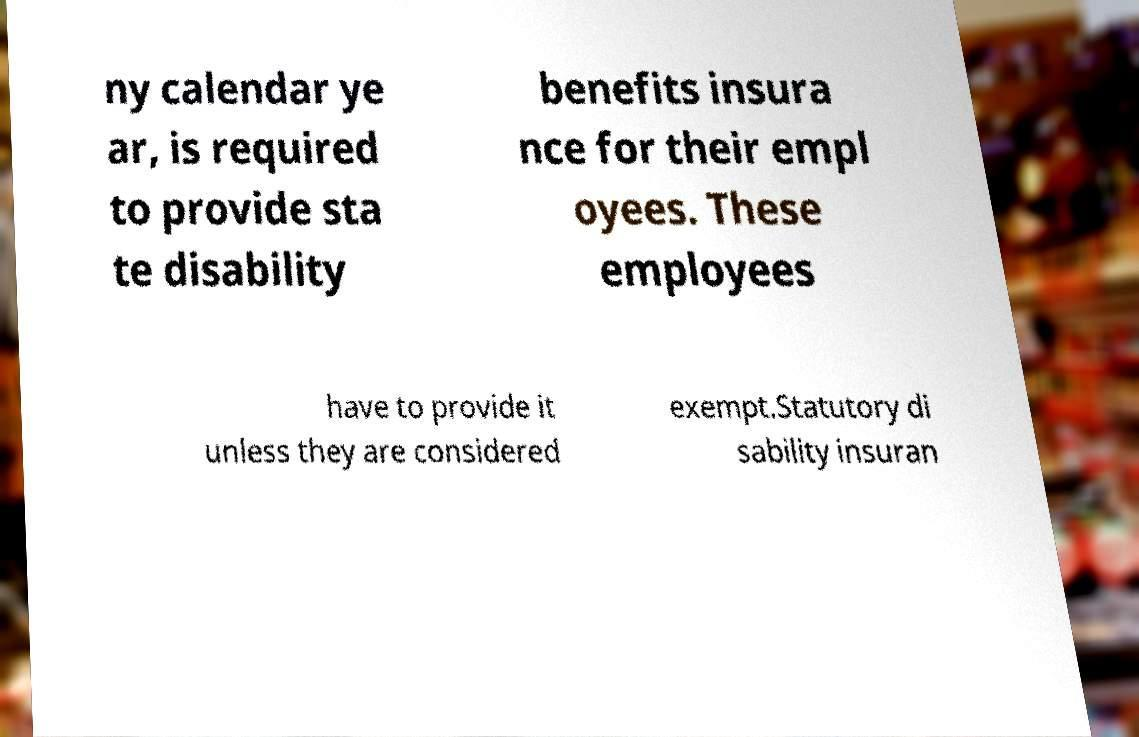There's text embedded in this image that I need extracted. Can you transcribe it verbatim? ny calendar ye ar, is required to provide sta te disability benefits insura nce for their empl oyees. These employees have to provide it unless they are considered exempt.Statutory di sability insuran 